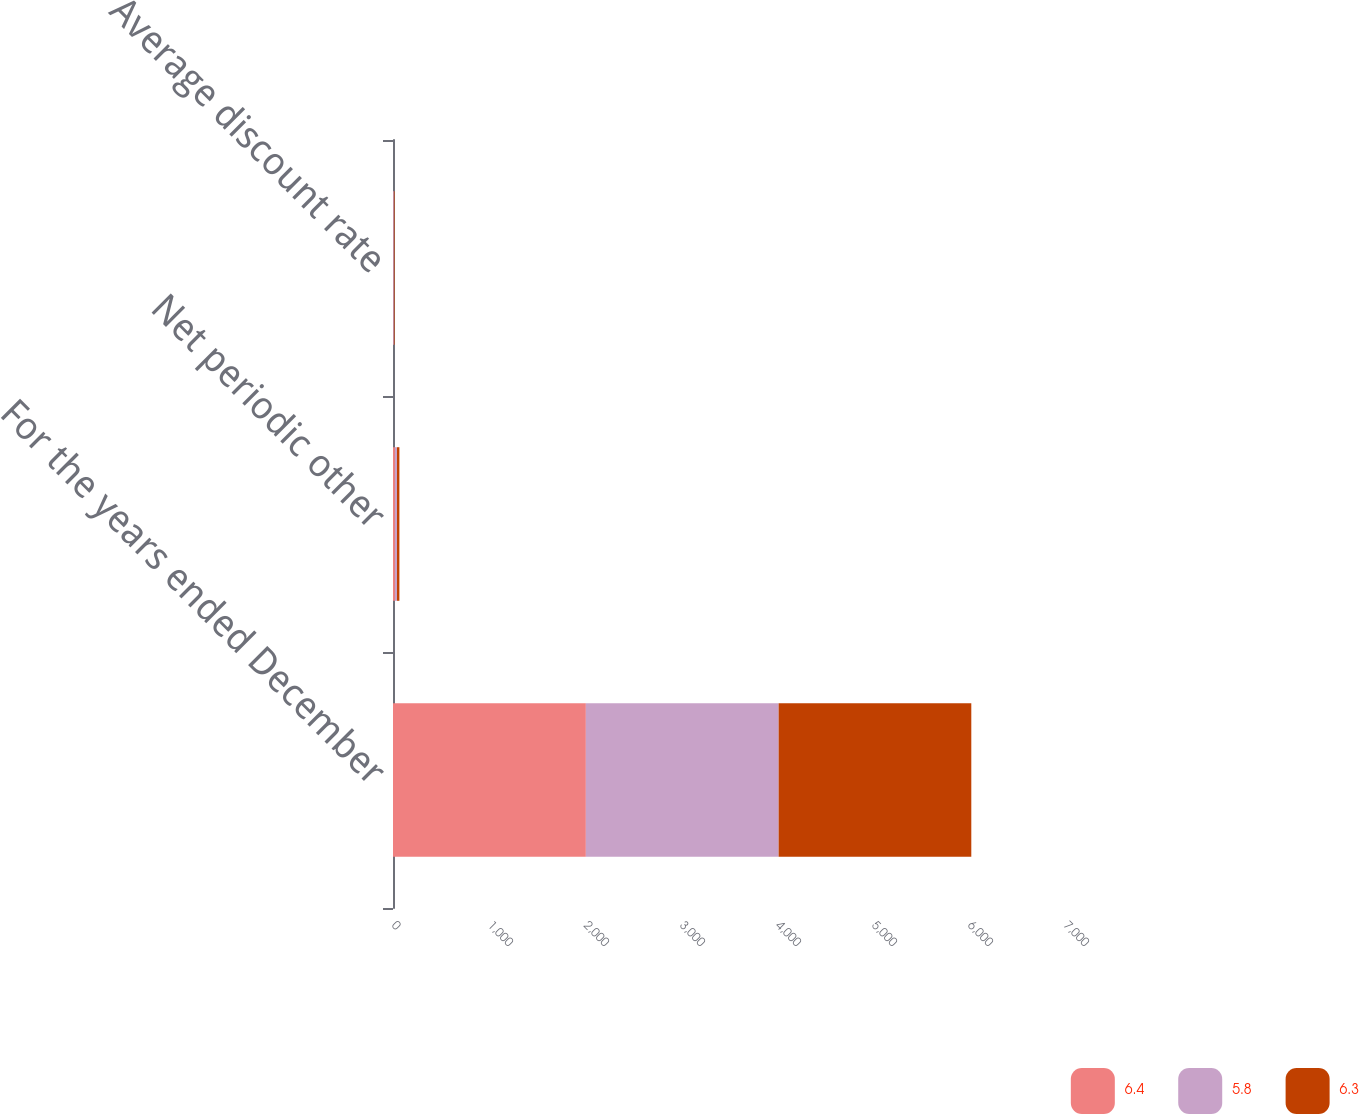<chart> <loc_0><loc_0><loc_500><loc_500><stacked_bar_chart><ecel><fcel>For the years ended December<fcel>Net periodic other<fcel>Average discount rate<nl><fcel>6.4<fcel>2009<fcel>19.9<fcel>6.4<nl><fcel>5.8<fcel>2008<fcel>21.9<fcel>6.3<nl><fcel>6.3<fcel>2007<fcel>24.9<fcel>5.8<nl></chart> 